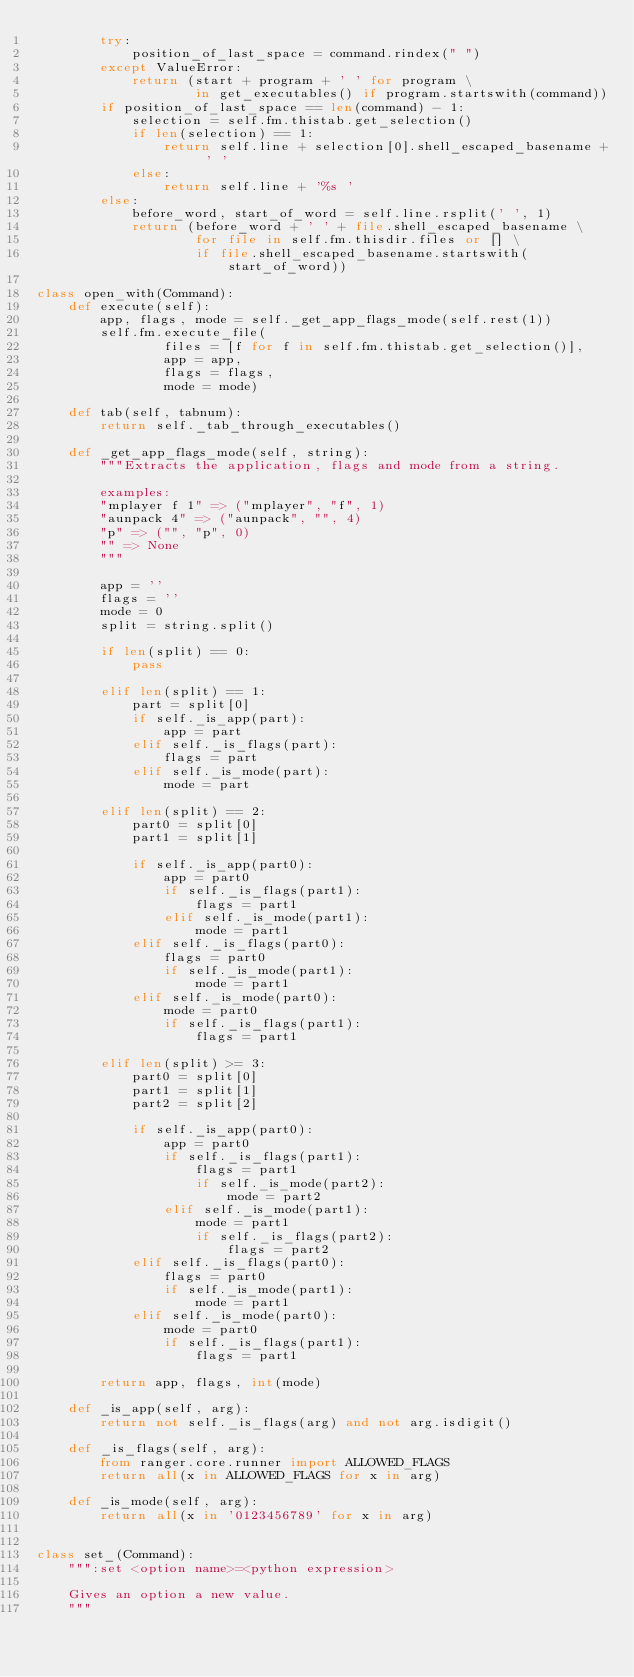<code> <loc_0><loc_0><loc_500><loc_500><_Python_>        try:
            position_of_last_space = command.rindex(" ")
        except ValueError:
            return (start + program + ' ' for program \
                    in get_executables() if program.startswith(command))
        if position_of_last_space == len(command) - 1:
            selection = self.fm.thistab.get_selection()
            if len(selection) == 1:
                return self.line + selection[0].shell_escaped_basename + ' '
            else:
                return self.line + '%s '
        else:
            before_word, start_of_word = self.line.rsplit(' ', 1)
            return (before_word + ' ' + file.shell_escaped_basename \
                    for file in self.fm.thisdir.files or [] \
                    if file.shell_escaped_basename.startswith(start_of_word))

class open_with(Command):
    def execute(self):
        app, flags, mode = self._get_app_flags_mode(self.rest(1))
        self.fm.execute_file(
                files = [f for f in self.fm.thistab.get_selection()],
                app = app,
                flags = flags,
                mode = mode)

    def tab(self, tabnum):
        return self._tab_through_executables()

    def _get_app_flags_mode(self, string):
        """Extracts the application, flags and mode from a string.

        examples:
        "mplayer f 1" => ("mplayer", "f", 1)
        "aunpack 4" => ("aunpack", "", 4)
        "p" => ("", "p", 0)
        "" => None
        """

        app = ''
        flags = ''
        mode = 0
        split = string.split()

        if len(split) == 0:
            pass

        elif len(split) == 1:
            part = split[0]
            if self._is_app(part):
                app = part
            elif self._is_flags(part):
                flags = part
            elif self._is_mode(part):
                mode = part

        elif len(split) == 2:
            part0 = split[0]
            part1 = split[1]

            if self._is_app(part0):
                app = part0
                if self._is_flags(part1):
                    flags = part1
                elif self._is_mode(part1):
                    mode = part1
            elif self._is_flags(part0):
                flags = part0
                if self._is_mode(part1):
                    mode = part1
            elif self._is_mode(part0):
                mode = part0
                if self._is_flags(part1):
                    flags = part1

        elif len(split) >= 3:
            part0 = split[0]
            part1 = split[1]
            part2 = split[2]

            if self._is_app(part0):
                app = part0
                if self._is_flags(part1):
                    flags = part1
                    if self._is_mode(part2):
                        mode = part2
                elif self._is_mode(part1):
                    mode = part1
                    if self._is_flags(part2):
                        flags = part2
            elif self._is_flags(part0):
                flags = part0
                if self._is_mode(part1):
                    mode = part1
            elif self._is_mode(part0):
                mode = part0
                if self._is_flags(part1):
                    flags = part1

        return app, flags, int(mode)

    def _is_app(self, arg):
        return not self._is_flags(arg) and not arg.isdigit()

    def _is_flags(self, arg):
        from ranger.core.runner import ALLOWED_FLAGS
        return all(x in ALLOWED_FLAGS for x in arg)

    def _is_mode(self, arg):
        return all(x in '0123456789' for x in arg)


class set_(Command):
    """:set <option name>=<python expression>

    Gives an option a new value.
    """</code> 